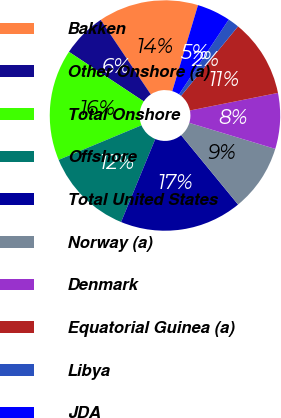Convert chart to OTSL. <chart><loc_0><loc_0><loc_500><loc_500><pie_chart><fcel>Bakken<fcel>Other Onshore (a)<fcel>Total Onshore<fcel>Offshore<fcel>Total United States<fcel>Norway (a)<fcel>Denmark<fcel>Equatorial Guinea (a)<fcel>Libya<fcel>JDA<nl><fcel>14.05%<fcel>6.26%<fcel>15.61%<fcel>12.49%<fcel>17.16%<fcel>9.38%<fcel>7.82%<fcel>10.93%<fcel>1.59%<fcel>4.71%<nl></chart> 